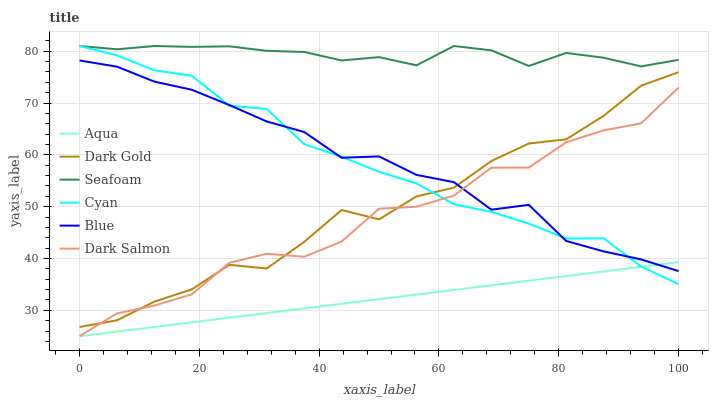Does Aqua have the minimum area under the curve?
Answer yes or no. Yes. Does Seafoam have the maximum area under the curve?
Answer yes or no. Yes. Does Dark Gold have the minimum area under the curve?
Answer yes or no. No. Does Dark Gold have the maximum area under the curve?
Answer yes or no. No. Is Aqua the smoothest?
Answer yes or no. Yes. Is Dark Salmon the roughest?
Answer yes or no. Yes. Is Dark Gold the smoothest?
Answer yes or no. No. Is Dark Gold the roughest?
Answer yes or no. No. Does Aqua have the lowest value?
Answer yes or no. Yes. Does Dark Gold have the lowest value?
Answer yes or no. No. Does Cyan have the highest value?
Answer yes or no. Yes. Does Dark Gold have the highest value?
Answer yes or no. No. Is Aqua less than Dark Gold?
Answer yes or no. Yes. Is Seafoam greater than Blue?
Answer yes or no. Yes. Does Cyan intersect Dark Salmon?
Answer yes or no. Yes. Is Cyan less than Dark Salmon?
Answer yes or no. No. Is Cyan greater than Dark Salmon?
Answer yes or no. No. Does Aqua intersect Dark Gold?
Answer yes or no. No. 